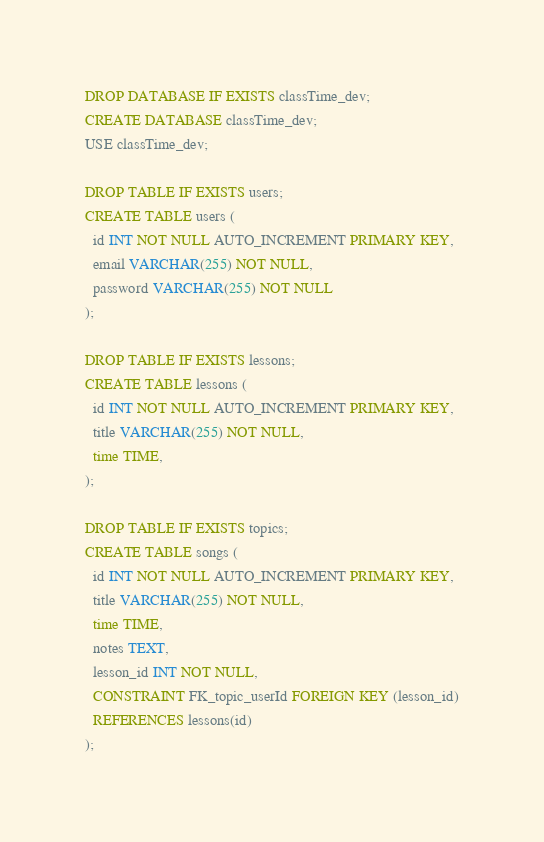<code> <loc_0><loc_0><loc_500><loc_500><_SQL_>DROP DATABASE IF EXISTS classTime_dev;
CREATE DATABASE classTime_dev;
USE classTime_dev;

DROP TABLE IF EXISTS users;
CREATE TABLE users (
  id INT NOT NULL AUTO_INCREMENT PRIMARY KEY,
  email VARCHAR(255) NOT NULL,
  password VARCHAR(255) NOT NULL
);

DROP TABLE IF EXISTS lessons;
CREATE TABLE lessons (
  id INT NOT NULL AUTO_INCREMENT PRIMARY KEY,
  title VARCHAR(255) NOT NULL,
  time TIME,
);

DROP TABLE IF EXISTS topics;
CREATE TABLE songs (
  id INT NOT NULL AUTO_INCREMENT PRIMARY KEY,
  title VARCHAR(255) NOT NULL,
  time TIME,
  notes TEXT,
  lesson_id INT NOT NULL,
  CONSTRAINT FK_topic_userId FOREIGN KEY (lesson_id)
  REFERENCES lessons(id)
);
</code> 